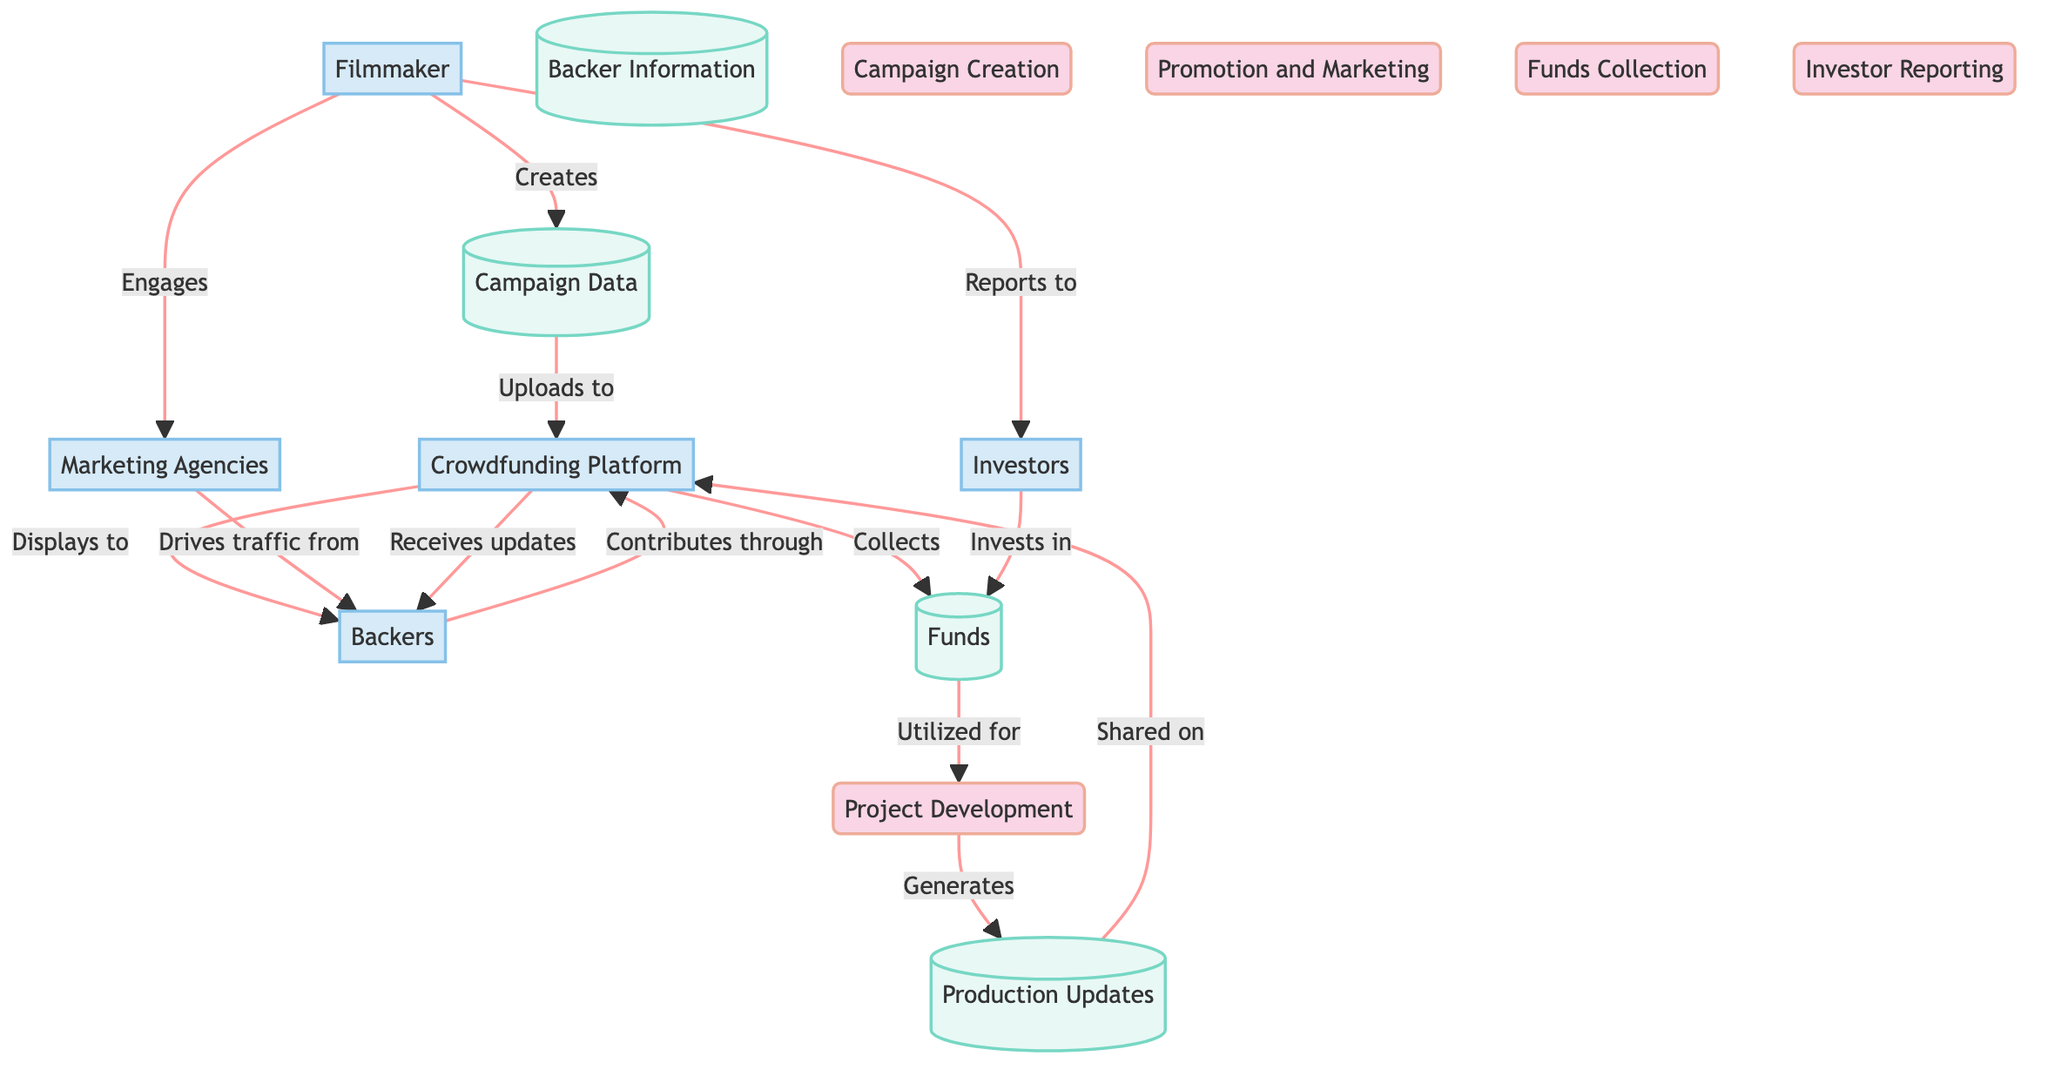What is the first process in the diagram? The first process listed in the diagram is "Campaign Creation," which is identified as P1. This is the starting point for the crowdfunding campaign.
Answer: Campaign Creation How many external entities are present? The diagram contains five external entities, which include the Filmmaker, Backers, Crowdfunding Platform, Marketing Agencies, and Investors.
Answer: 5 What type of data does the "Funds" datastore hold? The "Funds" datastore is designated to store the collected funds from backers and further investments made beyond the crowdfunding stage.
Answer: Collected funds What is the sole destination for funds after they are collected? According to the diagram, the sole destination for funds after being collected is the project development process, where the funds are utilized for various production activities.
Answer: Project Development Which two entities are involved in promoting the crowdfunding campaign? The two entities involved in promoting the crowdfunding campaign are the Filmmaker and Marketing Agencies. The Filmmaker engages Marketing Agencies to help drive traffic to potential backers.
Answer: Filmmaker and Marketing Agencies What do backers receive on the crowdfunding platform? Backers receive updates on the project's progress which is shared through the crowdfunding platform. This keeps them informed about developments related to the film.
Answer: Updates on the project's progress Where do filmmakers report the progress of the film? Filmmakers report the progress of the film to the Investors, keeping them updated with financial reports and project developments.
Answer: Investors How does the campaign data transition to the crowdfunding platform? The campaign data is uploaded to the crowdfunding platform after it has been created by the filmmaker. This is a direct flow from the campaign data datastore to the crowdfunding platform.
Answer: Uploaded to the crowdfunding platform What results from the project development process? The project development process generates production updates, signifying ongoing developments and changes during the film's production. These updates are later shared with backers and investors.
Answer: Production Updates 